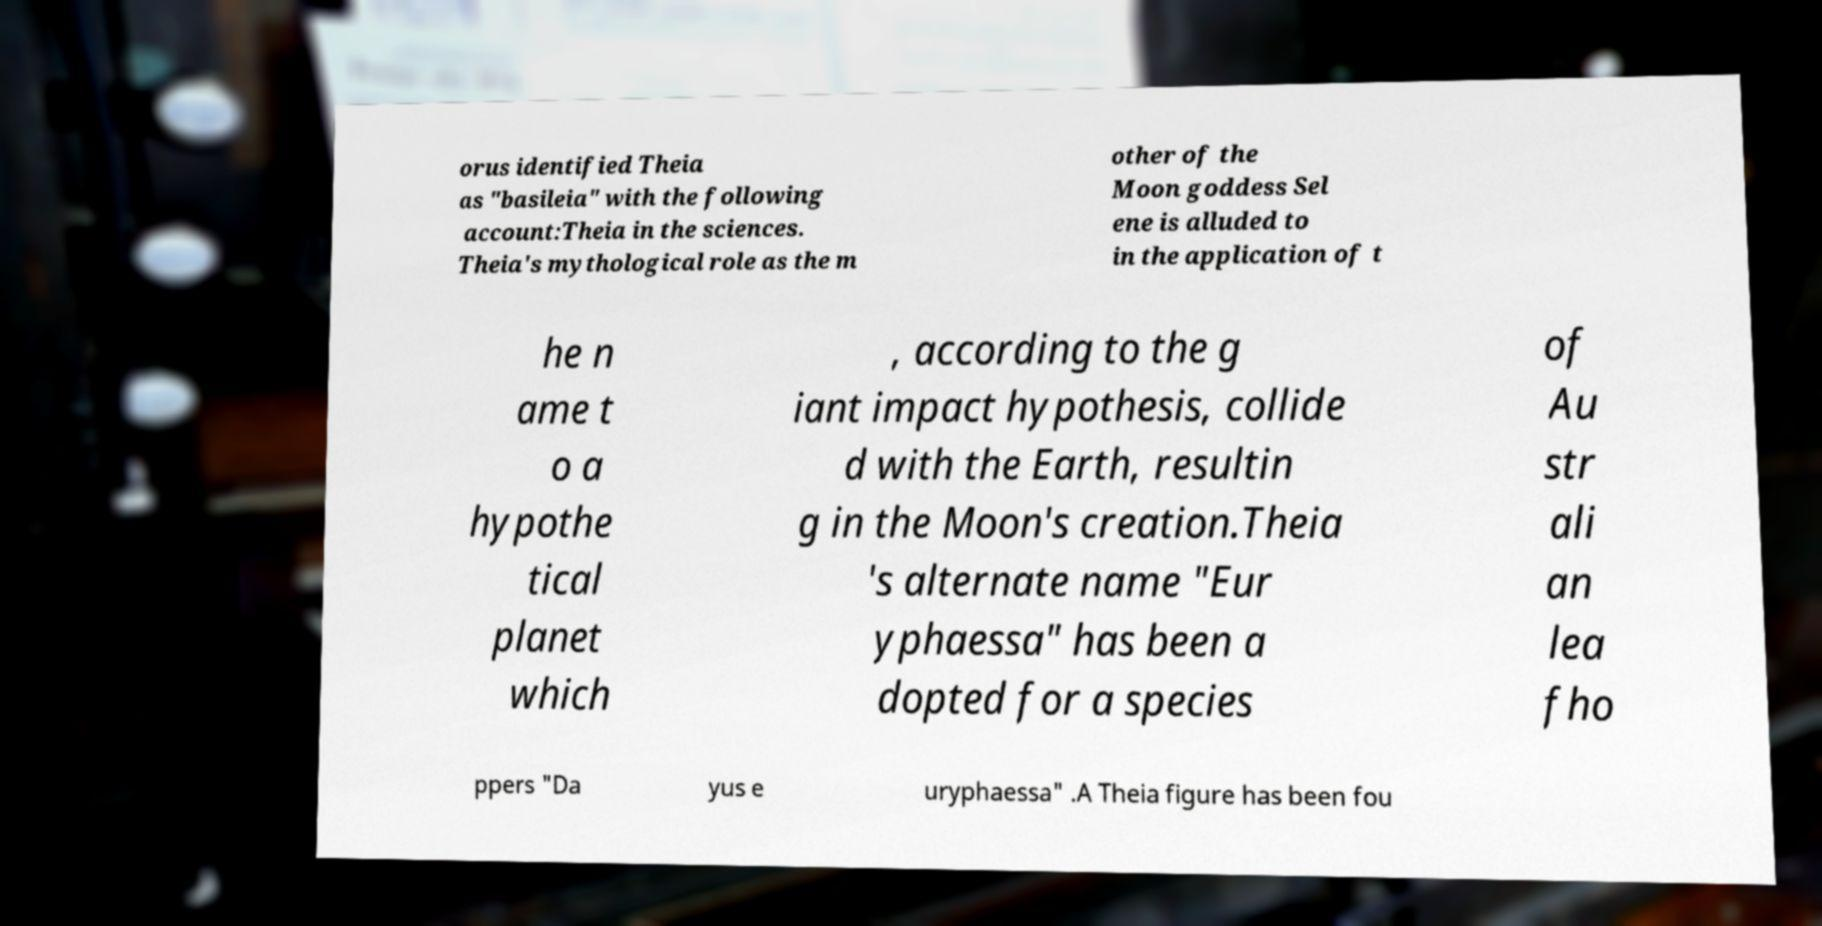Please identify and transcribe the text found in this image. orus identified Theia as "basileia" with the following account:Theia in the sciences. Theia's mythological role as the m other of the Moon goddess Sel ene is alluded to in the application of t he n ame t o a hypothe tical planet which , according to the g iant impact hypothesis, collide d with the Earth, resultin g in the Moon's creation.Theia 's alternate name "Eur yphaessa" has been a dopted for a species of Au str ali an lea fho ppers "Da yus e uryphaessa" .A Theia figure has been fou 